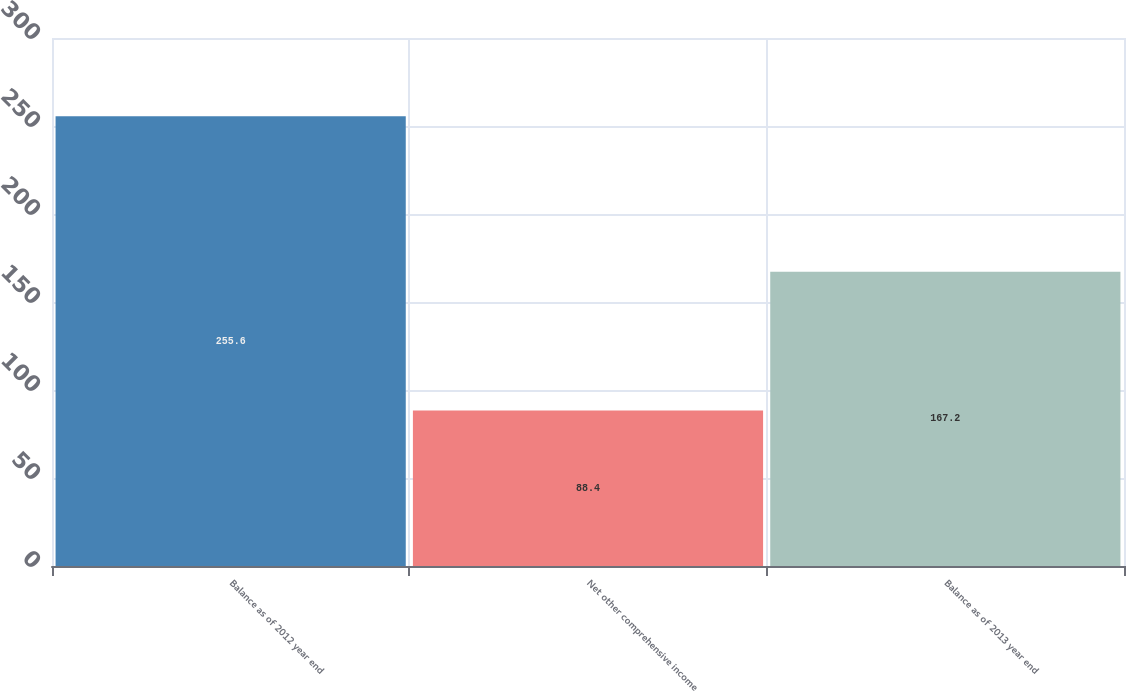Convert chart to OTSL. <chart><loc_0><loc_0><loc_500><loc_500><bar_chart><fcel>Balance as of 2012 year end<fcel>Net other comprehensive income<fcel>Balance as of 2013 year end<nl><fcel>255.6<fcel>88.4<fcel>167.2<nl></chart> 